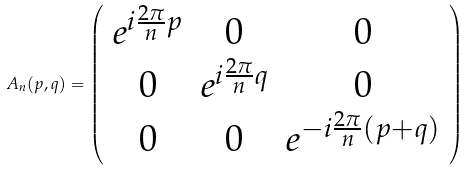Convert formula to latex. <formula><loc_0><loc_0><loc_500><loc_500>A _ { n } ( p , q ) = \left ( \begin{array} { c c c } e ^ { i \frac { 2 \pi } { n } p } & 0 & 0 \\ 0 & e ^ { i \frac { 2 \pi } { n } q } & 0 \\ 0 & 0 & e ^ { - i \frac { 2 \pi } { n } ( p + q ) } \\ \end{array} \right )</formula> 